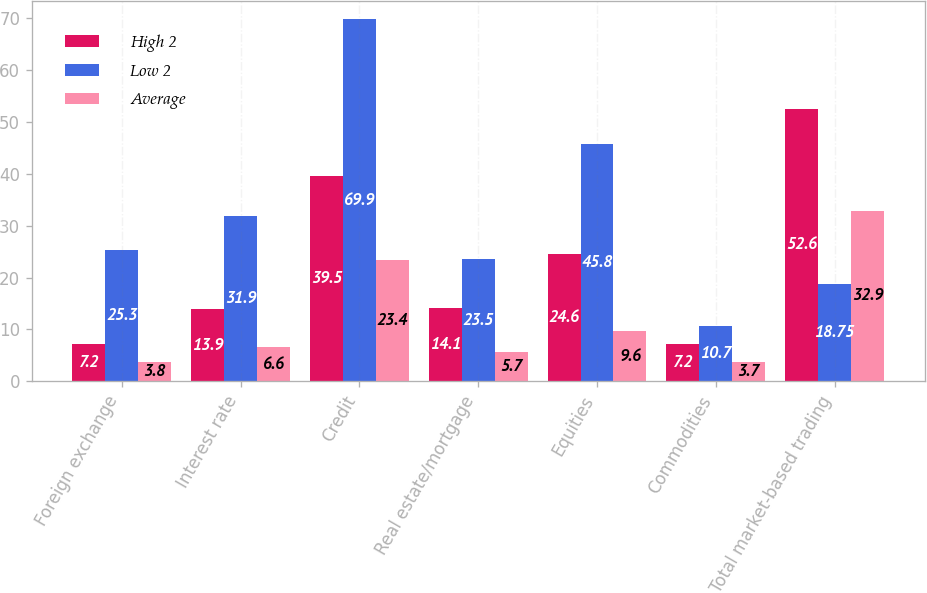Convert chart. <chart><loc_0><loc_0><loc_500><loc_500><stacked_bar_chart><ecel><fcel>Foreign exchange<fcel>Interest rate<fcel>Credit<fcel>Real estate/mortgage<fcel>Equities<fcel>Commodities<fcel>Total market-based trading<nl><fcel>High 2<fcel>7.2<fcel>13.9<fcel>39.5<fcel>14.1<fcel>24.6<fcel>7.2<fcel>52.6<nl><fcel>Low 2<fcel>25.3<fcel>31.9<fcel>69.9<fcel>23.5<fcel>45.8<fcel>10.7<fcel>18.75<nl><fcel>Average<fcel>3.8<fcel>6.6<fcel>23.4<fcel>5.7<fcel>9.6<fcel>3.7<fcel>32.9<nl></chart> 